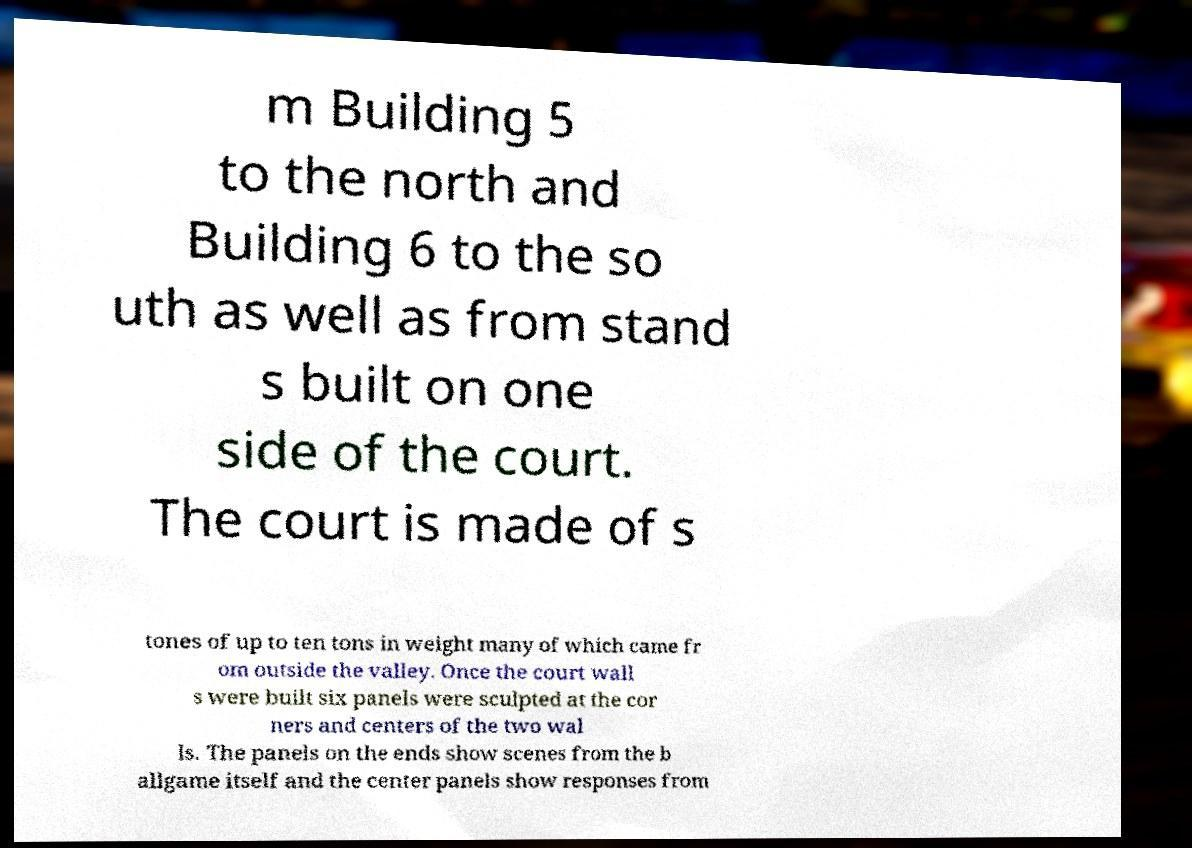Please identify and transcribe the text found in this image. m Building 5 to the north and Building 6 to the so uth as well as from stand s built on one side of the court. The court is made of s tones of up to ten tons in weight many of which came fr om outside the valley. Once the court wall s were built six panels were sculpted at the cor ners and centers of the two wal ls. The panels on the ends show scenes from the b allgame itself and the center panels show responses from 